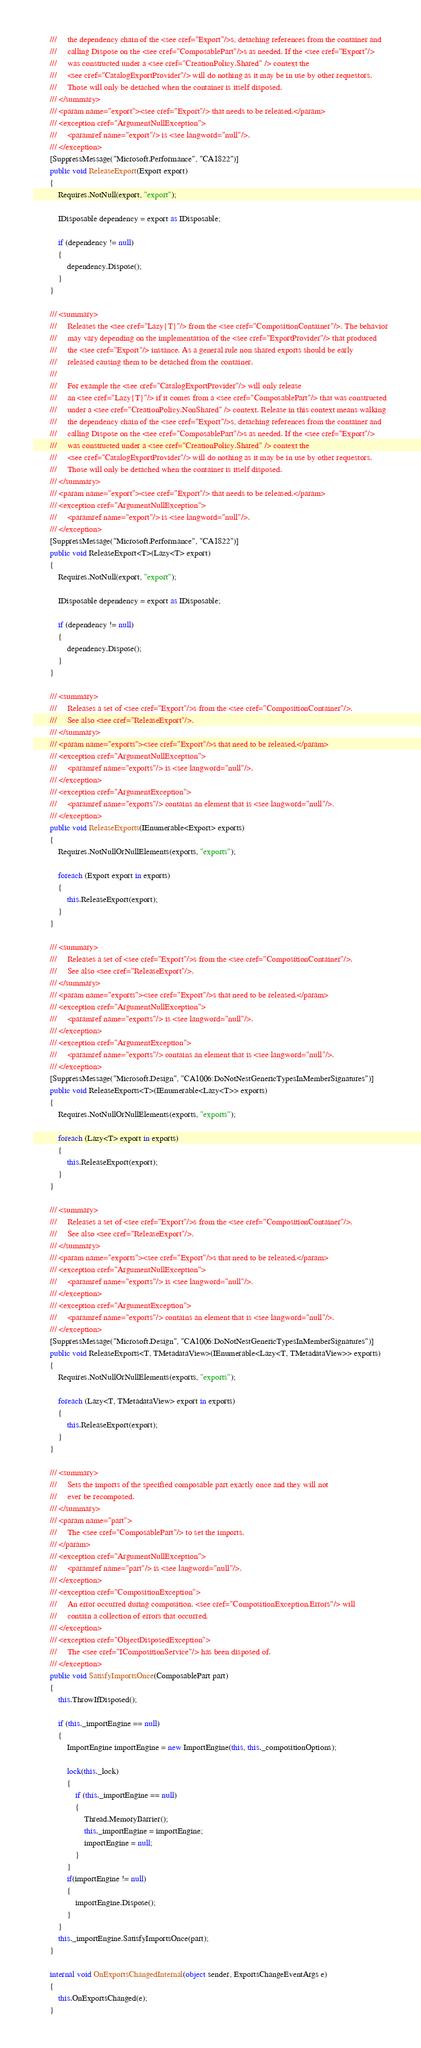Convert code to text. <code><loc_0><loc_0><loc_500><loc_500><_C#_>        ///     the dependency chain of the <see cref="Export"/>s, detaching references from the container and 
        ///     calling Dispose on the <see cref="ComposablePart"/>s as needed. If the <see cref="Export"/> 
        ///     was constructed under a <see cref="CreationPolicy.Shared" /> context the 
        ///     <see cref="CatalogExportProvider"/> will do nothing as it may be in use by other requestors. 
        ///     Those will only be detached when the container is itself disposed.
        /// </summary>
        /// <param name="export"><see cref="Export"/> that needs to be released.</param>
        /// <exception cref="ArgumentNullException">
        ///     <paramref name="export"/> is <see langword="null"/>.
        /// </exception>
        [SuppressMessage("Microsoft.Performance", "CA1822")]
        public void ReleaseExport(Export export)
        {
            Requires.NotNull(export, "export");

            IDisposable dependency = export as IDisposable;

            if (dependency != null)
            {
                dependency.Dispose();
            }
        }

        /// <summary>
        ///     Releases the <see cref="Lazy{T}"/> from the <see cref="CompositionContainer"/>. The behavior
        ///     may vary depending on the implementation of the <see cref="ExportProvider"/> that produced 
        ///     the <see cref="Export"/> instance. As a general rule non shared exports should be early 
        ///     released causing them to be detached from the container.
        ///
        ///     For example the <see cref="CatalogExportProvider"/> will only release 
        ///     an <see cref="Lazy{T}"/> if it comes from a <see cref="ComposablePart"/> that was constructed
        ///     under a <see cref="CreationPolicy.NonShared" /> context. Release in this context means walking
        ///     the dependency chain of the <see cref="Export"/>s, detaching references from the container and 
        ///     calling Dispose on the <see cref="ComposablePart"/>s as needed. If the <see cref="Export"/> 
        ///     was constructed under a <see cref="CreationPolicy.Shared" /> context the 
        ///     <see cref="CatalogExportProvider"/> will do nothing as it may be in use by other requestors. 
        ///     Those will only be detached when the container is itself disposed.
        /// </summary>
        /// <param name="export"><see cref="Export"/> that needs to be released.</param>
        /// <exception cref="ArgumentNullException">
        ///     <paramref name="export"/> is <see langword="null"/>.
        /// </exception>
        [SuppressMessage("Microsoft.Performance", "CA1822")]
        public void ReleaseExport<T>(Lazy<T> export)
        {
            Requires.NotNull(export, "export");

            IDisposable dependency = export as IDisposable;

            if (dependency != null)
            {
                dependency.Dispose();
            }
        }

        /// <summary>
        ///     Releases a set of <see cref="Export"/>s from the <see cref="CompositionContainer"/>. 
        ///     See also <see cref="ReleaseExport"/>.
        /// </summary>
        /// <param name="exports"><see cref="Export"/>s that need to be released.</param>
        /// <exception cref="ArgumentNullException">
        ///     <paramref name="exports"/> is <see langword="null"/>.
        /// </exception>
        /// <exception cref="ArgumentException">
        ///     <paramref name="exports"/> contains an element that is <see langword="null"/>.
        /// </exception>
        public void ReleaseExports(IEnumerable<Export> exports)
        {
            Requires.NotNullOrNullElements(exports, "exports");

            foreach (Export export in exports)
            {
                this.ReleaseExport(export);
            }
        }

        /// <summary>
        ///     Releases a set of <see cref="Export"/>s from the <see cref="CompositionContainer"/>. 
        ///     See also <see cref="ReleaseExport"/>.
        /// </summary>
        /// <param name="exports"><see cref="Export"/>s that need to be released.</param>
        /// <exception cref="ArgumentNullException">
        ///     <paramref name="exports"/> is <see langword="null"/>.
        /// </exception>
        /// <exception cref="ArgumentException">
        ///     <paramref name="exports"/> contains an element that is <see langword="null"/>.
        /// </exception>
        [SuppressMessage("Microsoft.Design", "CA1006:DoNotNestGenericTypesInMemberSignatures")]
        public void ReleaseExports<T>(IEnumerable<Lazy<T>> exports)
        {
            Requires.NotNullOrNullElements(exports, "exports");

            foreach (Lazy<T> export in exports)
            {
                this.ReleaseExport(export);
            }
        }

        /// <summary>
        ///     Releases a set of <see cref="Export"/>s from the <see cref="CompositionContainer"/>. 
        ///     See also <see cref="ReleaseExport"/>.
        /// </summary>
        /// <param name="exports"><see cref="Export"/>s that need to be released.</param>
        /// <exception cref="ArgumentNullException">
        ///     <paramref name="exports"/> is <see langword="null"/>.
        /// </exception>
        /// <exception cref="ArgumentException">
        ///     <paramref name="exports"/> contains an element that is <see langword="null"/>.
        /// </exception>
        [SuppressMessage("Microsoft.Design", "CA1006:DoNotNestGenericTypesInMemberSignatures")]
        public void ReleaseExports<T, TMetadataView>(IEnumerable<Lazy<T, TMetadataView>> exports)
        {
            Requires.NotNullOrNullElements(exports, "exports");

            foreach (Lazy<T, TMetadataView> export in exports)
            {
                this.ReleaseExport(export);
            }
        }

        /// <summary>
        ///     Sets the imports of the specified composable part exactly once and they will not
        ///     ever be recomposed.
        /// </summary>
        /// <param name="part">
        ///     The <see cref="ComposablePart"/> to set the imports.
        /// </param>
        /// <exception cref="ArgumentNullException">
        ///     <paramref name="part"/> is <see langword="null"/>.
        /// </exception>
        /// <exception cref="CompositionException">
        ///     An error occurred during composition. <see cref="CompositionException.Errors"/> will
        ///     contain a collection of errors that occurred.
        /// </exception>
        /// <exception cref="ObjectDisposedException">
        ///     The <see cref="ICompositionService"/> has been disposed of.
        /// </exception>
        public void SatisfyImportsOnce(ComposablePart part)
        {
            this.ThrowIfDisposed();
            
            if (this._importEngine == null)
            {
                ImportEngine importEngine = new ImportEngine(this, this._compositionOptions);
                
                lock(this._lock)
                {
                    if (this._importEngine == null)
                    {
                        Thread.MemoryBarrier();
                        this._importEngine = importEngine;
                        importEngine = null;
                    }
                }
                if(importEngine != null)
                {
                    importEngine.Dispose();
                }
            }
            this._importEngine.SatisfyImportsOnce(part);
        }

        internal void OnExportsChangedInternal(object sender, ExportsChangeEventArgs e)
        {
            this.OnExportsChanged(e);
        }
</code> 